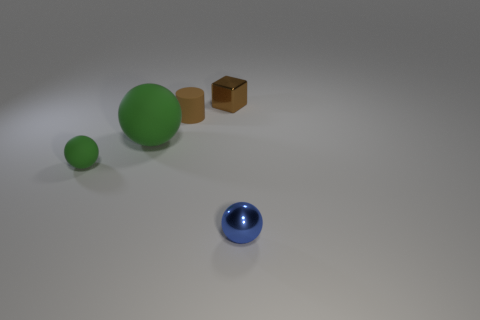Does the tiny block have the same color as the cylinder?
Provide a short and direct response. Yes. The blue sphere that is the same material as the cube is what size?
Offer a very short reply. Small. How many things are the same color as the metallic block?
Your response must be concise. 1. Are there any matte cylinders on the left side of the cylinder?
Your answer should be compact. No. Does the small green object have the same shape as the matte object on the right side of the big rubber thing?
Offer a very short reply. No. What number of things are tiny spheres that are on the right side of the tiny green ball or small brown rubber cubes?
Provide a short and direct response. 1. Is there anything else that has the same material as the brown cube?
Provide a short and direct response. Yes. How many brown objects are both in front of the brown metallic object and on the right side of the brown matte cylinder?
Offer a terse response. 0. What number of objects are either tiny objects that are behind the tiny blue shiny object or green rubber objects that are right of the tiny green sphere?
Give a very brief answer. 4. How many other things are there of the same shape as the brown metallic thing?
Ensure brevity in your answer.  0. 